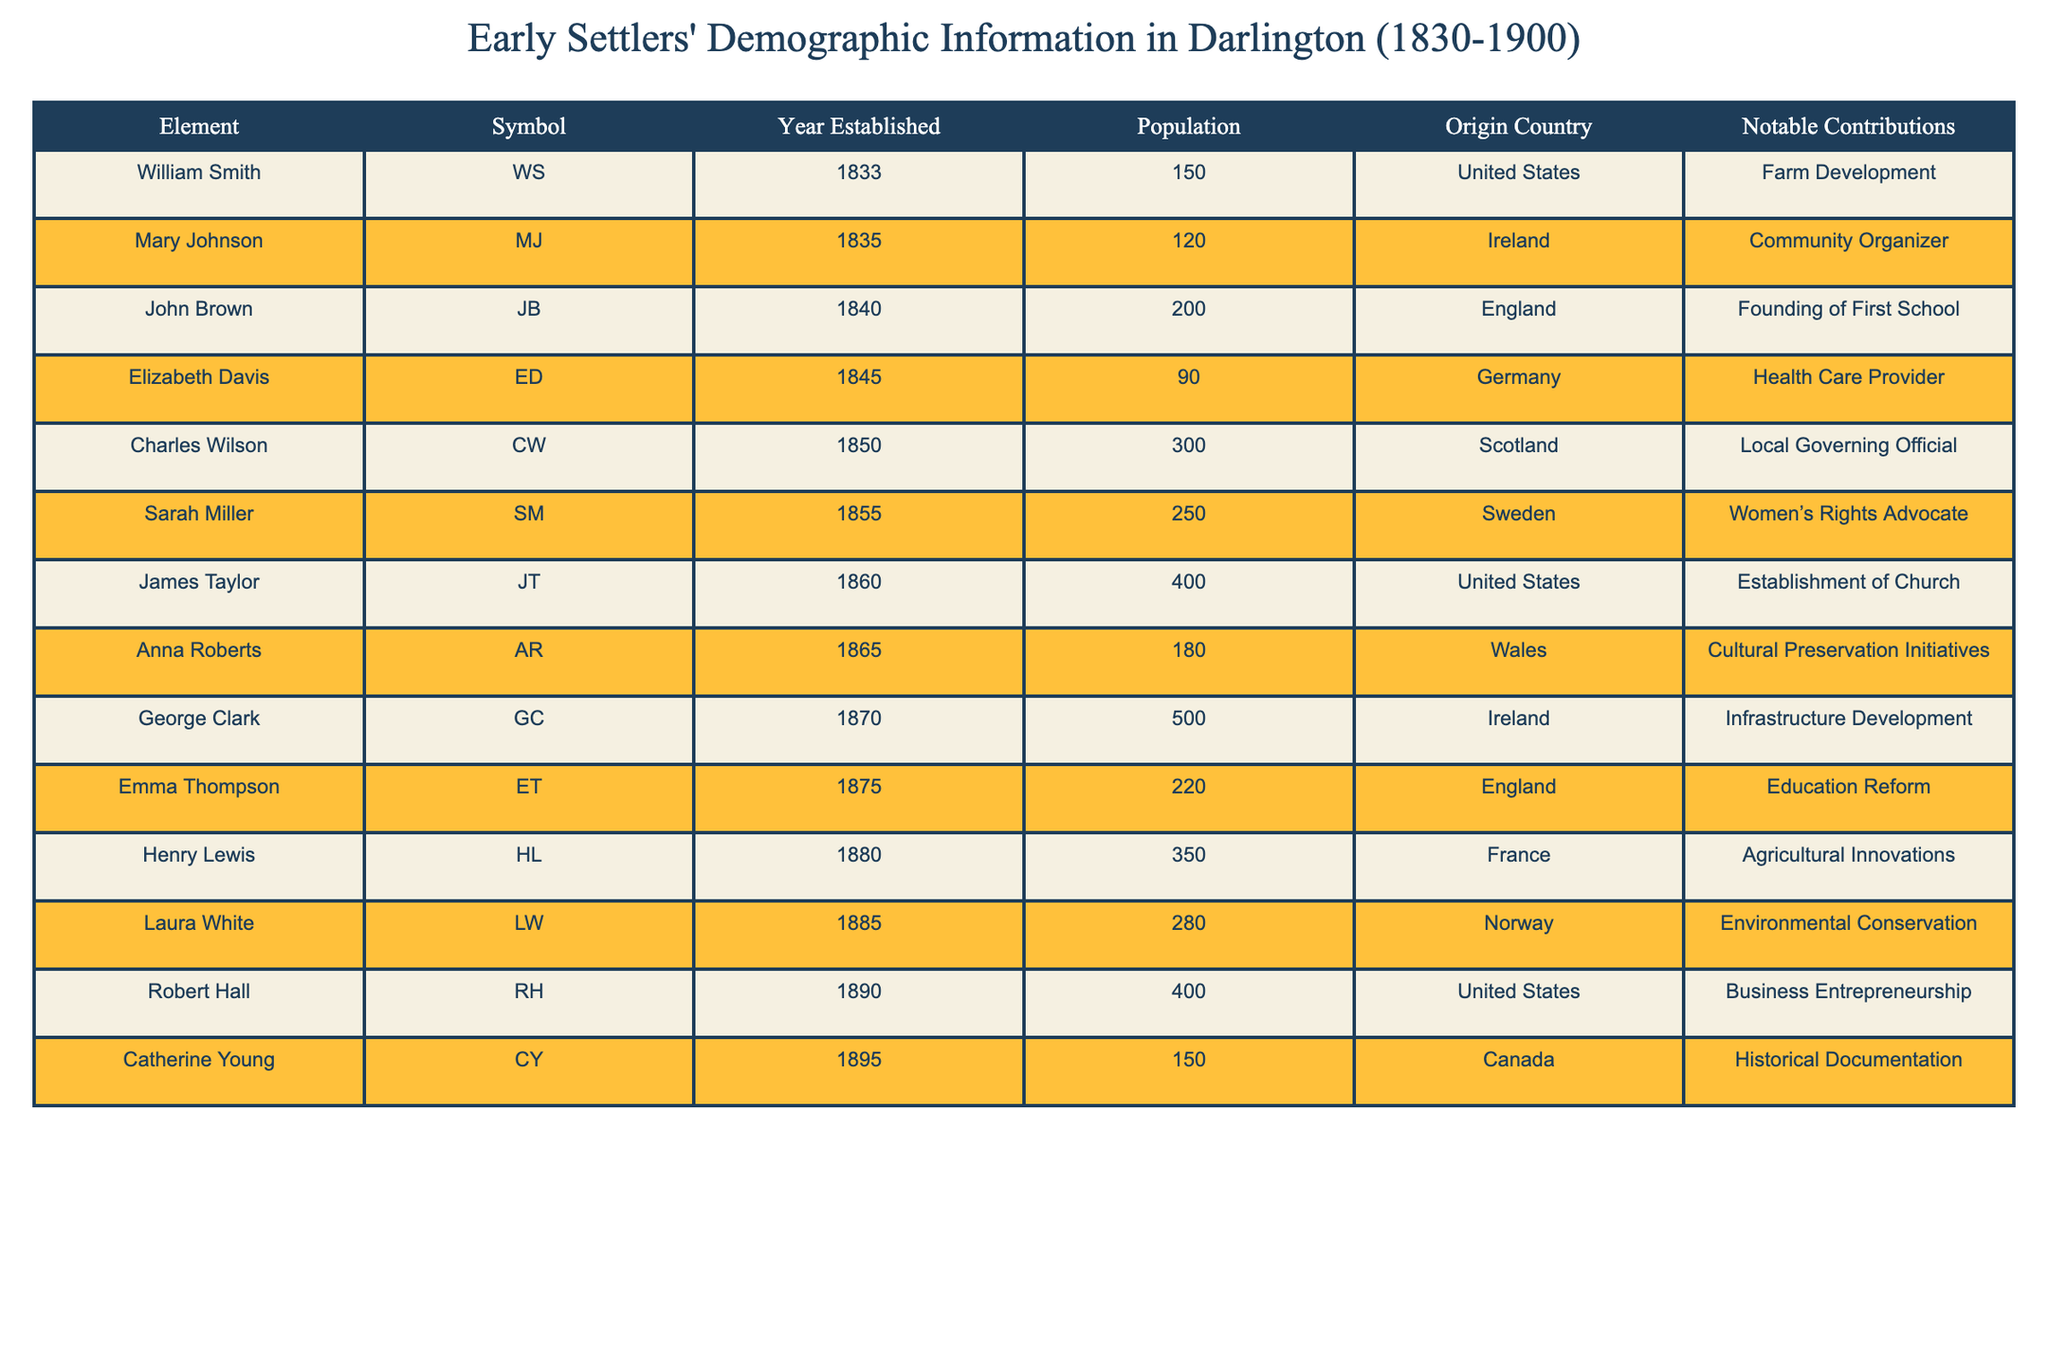What year was George Clark established? Looking at the table, I can see that George Clark is listed under the "Year Established" column, which shows he was established in 1870.
Answer: 1870 Which origin country had the highest population among the early settlers listed? By reviewing the "Population" column, I notice that Charles Wilson in 1850 had the highest population at 300. However, George Clark had a population of 500 in 1870, which is higher than Charles Wilson's. Therefore, the highest population is associated with Ireland (George Clark).
Answer: Ireland How many total settlers were established from the United States by 1900? To find the total number of settlers, I add the populations of William Smith (150), James Taylor (400), and Robert Hall (400). This gives me 150 + 400 + 400 = 950.
Answer: 950 Was Sarah Miller a notable advocate for women's rights? Yes, Sarah Miller is listed as a Women's Rights Advocate in the "Notable Contributions" column of the table, confirming this fact to be true.
Answer: Yes What was the average population of settlers from Canada and Norway? For Canada, Catherine Young had a population of 150, and for Norway, Laura White had a population of 280. The sum of these populations is 150 + 280 = 430, and since there are 2 data points, the average is 430/2 = 215.
Answer: 215 Did any settlers contribute to health care? Yes, Elizabeth Davis is noted as a Health Care Provider in the table, indicating her contribution was related to health care.
Answer: Yes Which origin country contributed to cultural preservation initiatives? According to the table, Anna Roberts from Wales contributed to Cultural Preservation Initiatives, as stated in the "Notable Contributions" column.
Answer: Wales What is the total population of settlers from Ireland by 1900? The table lists George Clark (500 in 1870) and Mary Johnson (120 in 1835) under Ireland. Adding these gives 500 + 120 = 620.
Answer: 620 Who among the settlers was connected to education reform? Emma Thompson is mentioned as contributing to Education Reform in the "Notable Contributions" column, confirming her connection.
Answer: Emma Thompson 